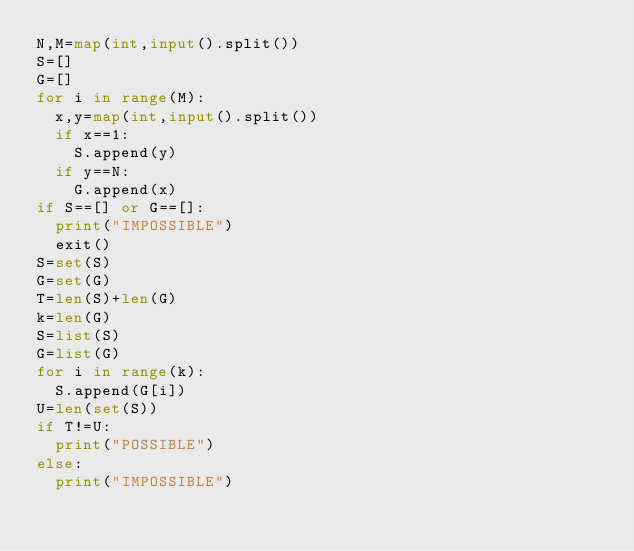Convert code to text. <code><loc_0><loc_0><loc_500><loc_500><_Python_>N,M=map(int,input().split())
S=[]
G=[]
for i in range(M):
	x,y=map(int,input().split())
	if x==1:
		S.append(y)
	if y==N:
		G.append(x)
if S==[] or G==[]:
	print("IMPOSSIBLE")
	exit()
S=set(S)
G=set(G)
T=len(S)+len(G)
k=len(G)
S=list(S)
G=list(G)
for i in range(k):
	S.append(G[i])
U=len(set(S))
if T!=U:
	print("POSSIBLE")
else:
	print("IMPOSSIBLE")</code> 